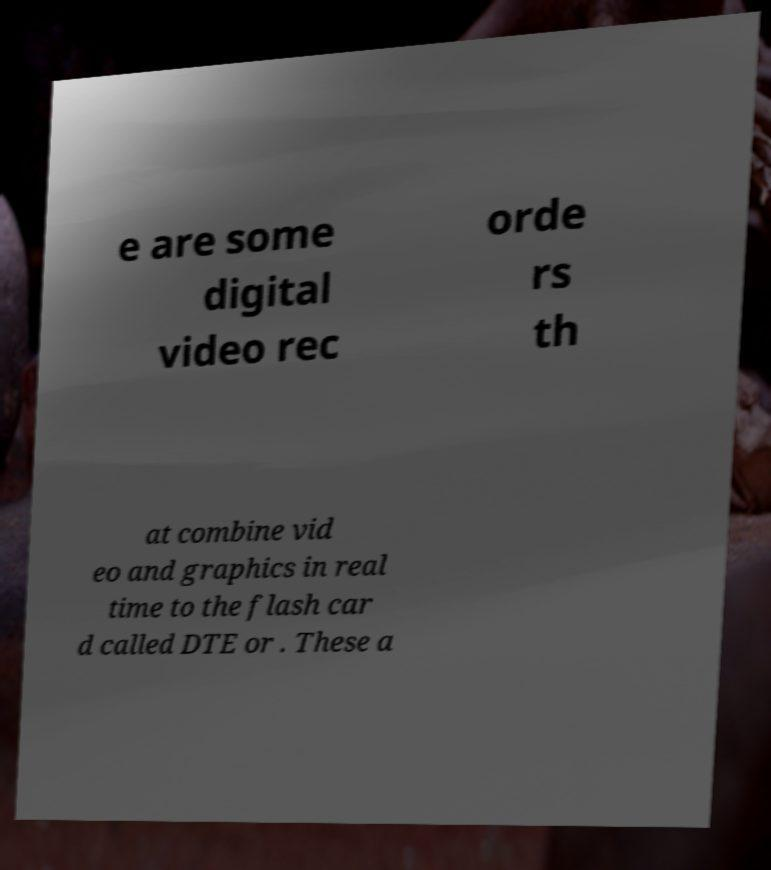I need the written content from this picture converted into text. Can you do that? e are some digital video rec orde rs th at combine vid eo and graphics in real time to the flash car d called DTE or . These a 